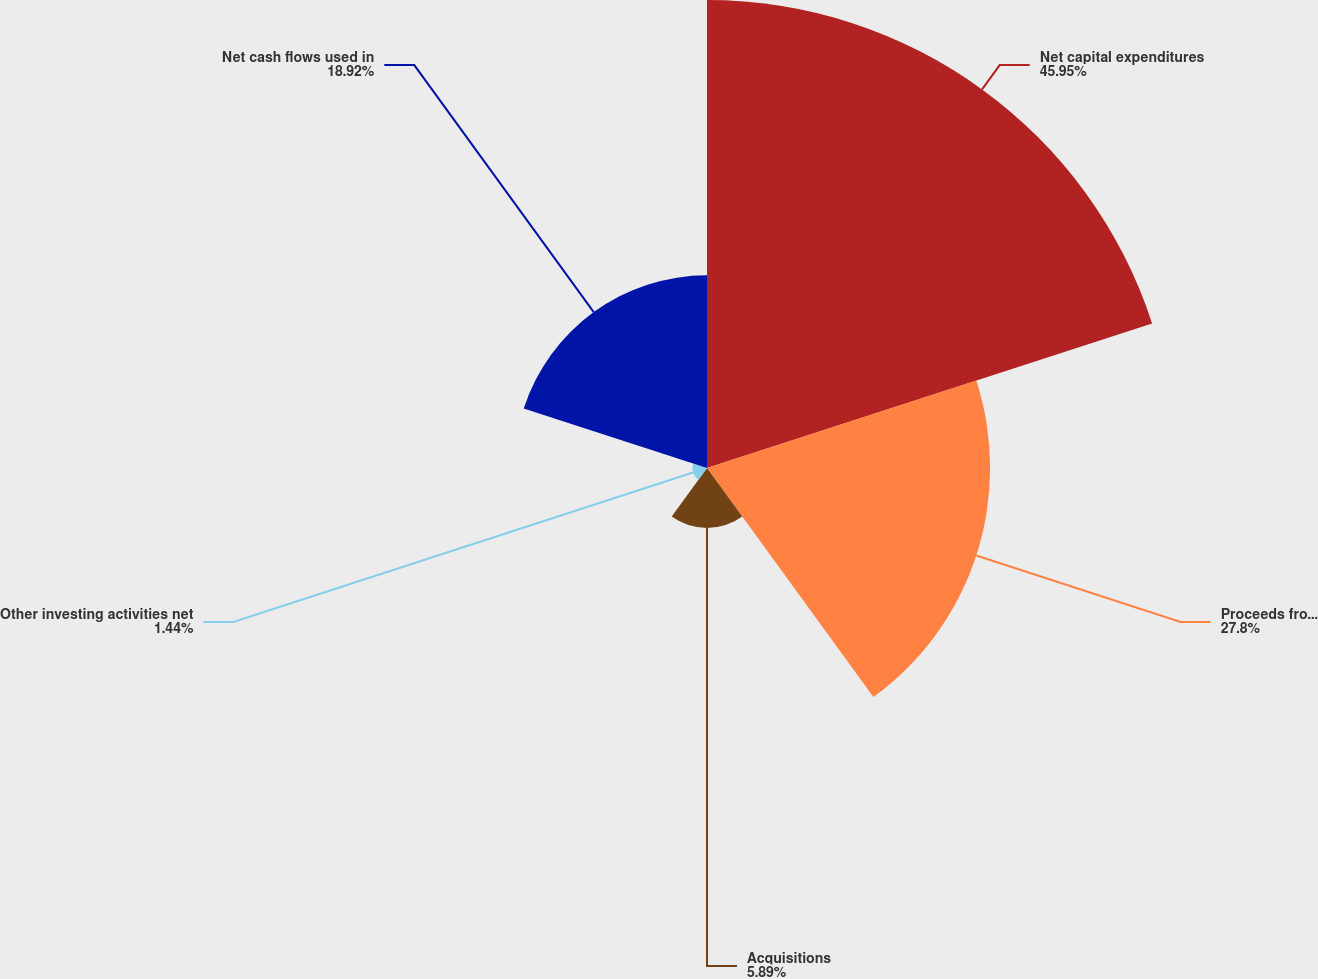Convert chart. <chart><loc_0><loc_0><loc_500><loc_500><pie_chart><fcel>Net capital expenditures<fcel>Proceeds from sale of assets<fcel>Acquisitions<fcel>Other investing activities net<fcel>Net cash flows used in<nl><fcel>45.95%<fcel>27.8%<fcel>5.89%<fcel>1.44%<fcel>18.92%<nl></chart> 